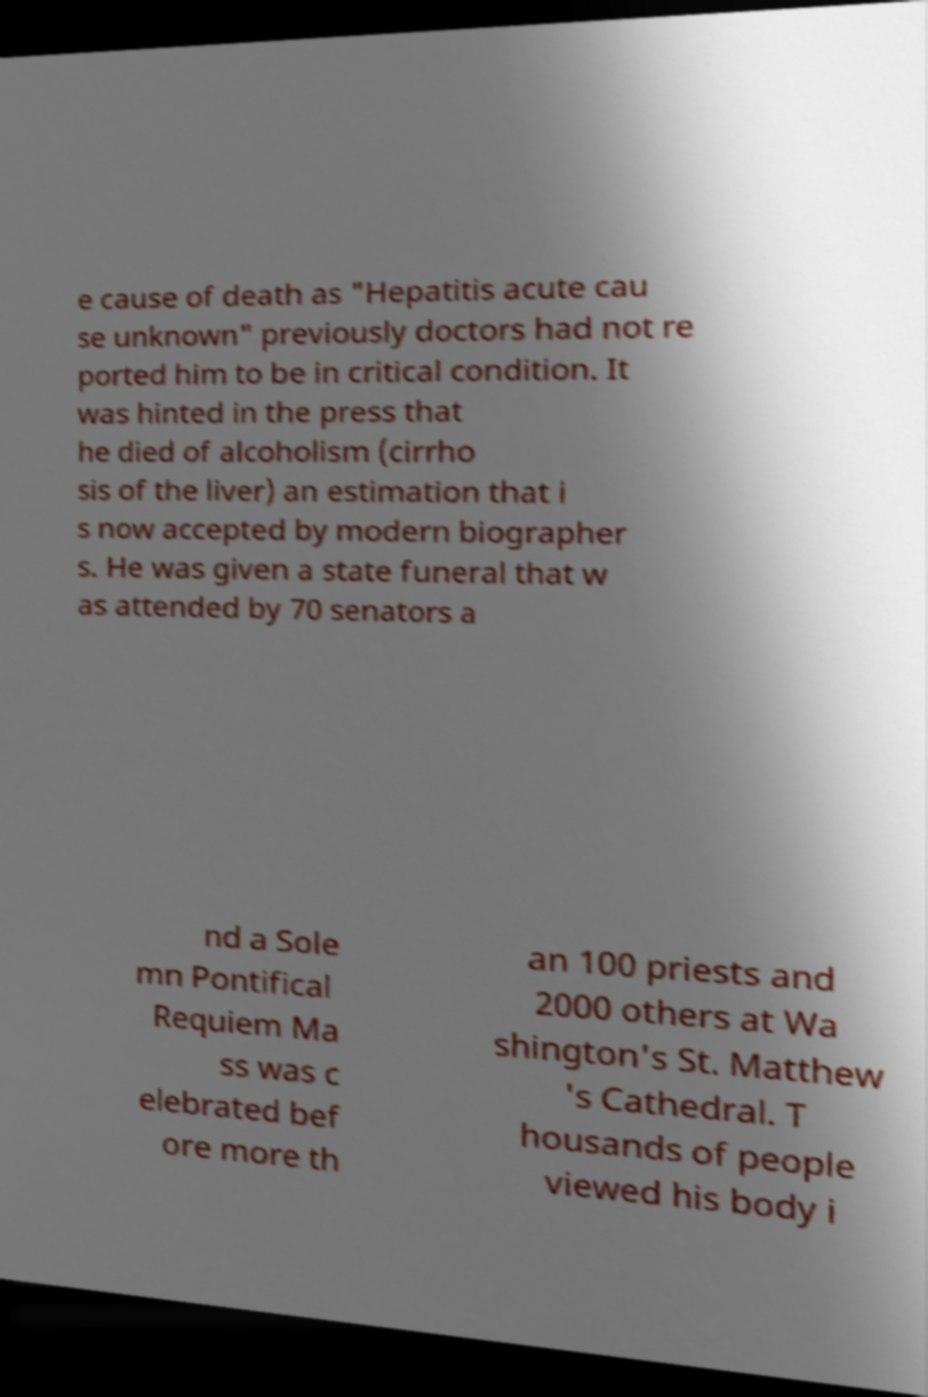There's text embedded in this image that I need extracted. Can you transcribe it verbatim? e cause of death as "Hepatitis acute cau se unknown" previously doctors had not re ported him to be in critical condition. It was hinted in the press that he died of alcoholism (cirrho sis of the liver) an estimation that i s now accepted by modern biographer s. He was given a state funeral that w as attended by 70 senators a nd a Sole mn Pontifical Requiem Ma ss was c elebrated bef ore more th an 100 priests and 2000 others at Wa shington's St. Matthew 's Cathedral. T housands of people viewed his body i 